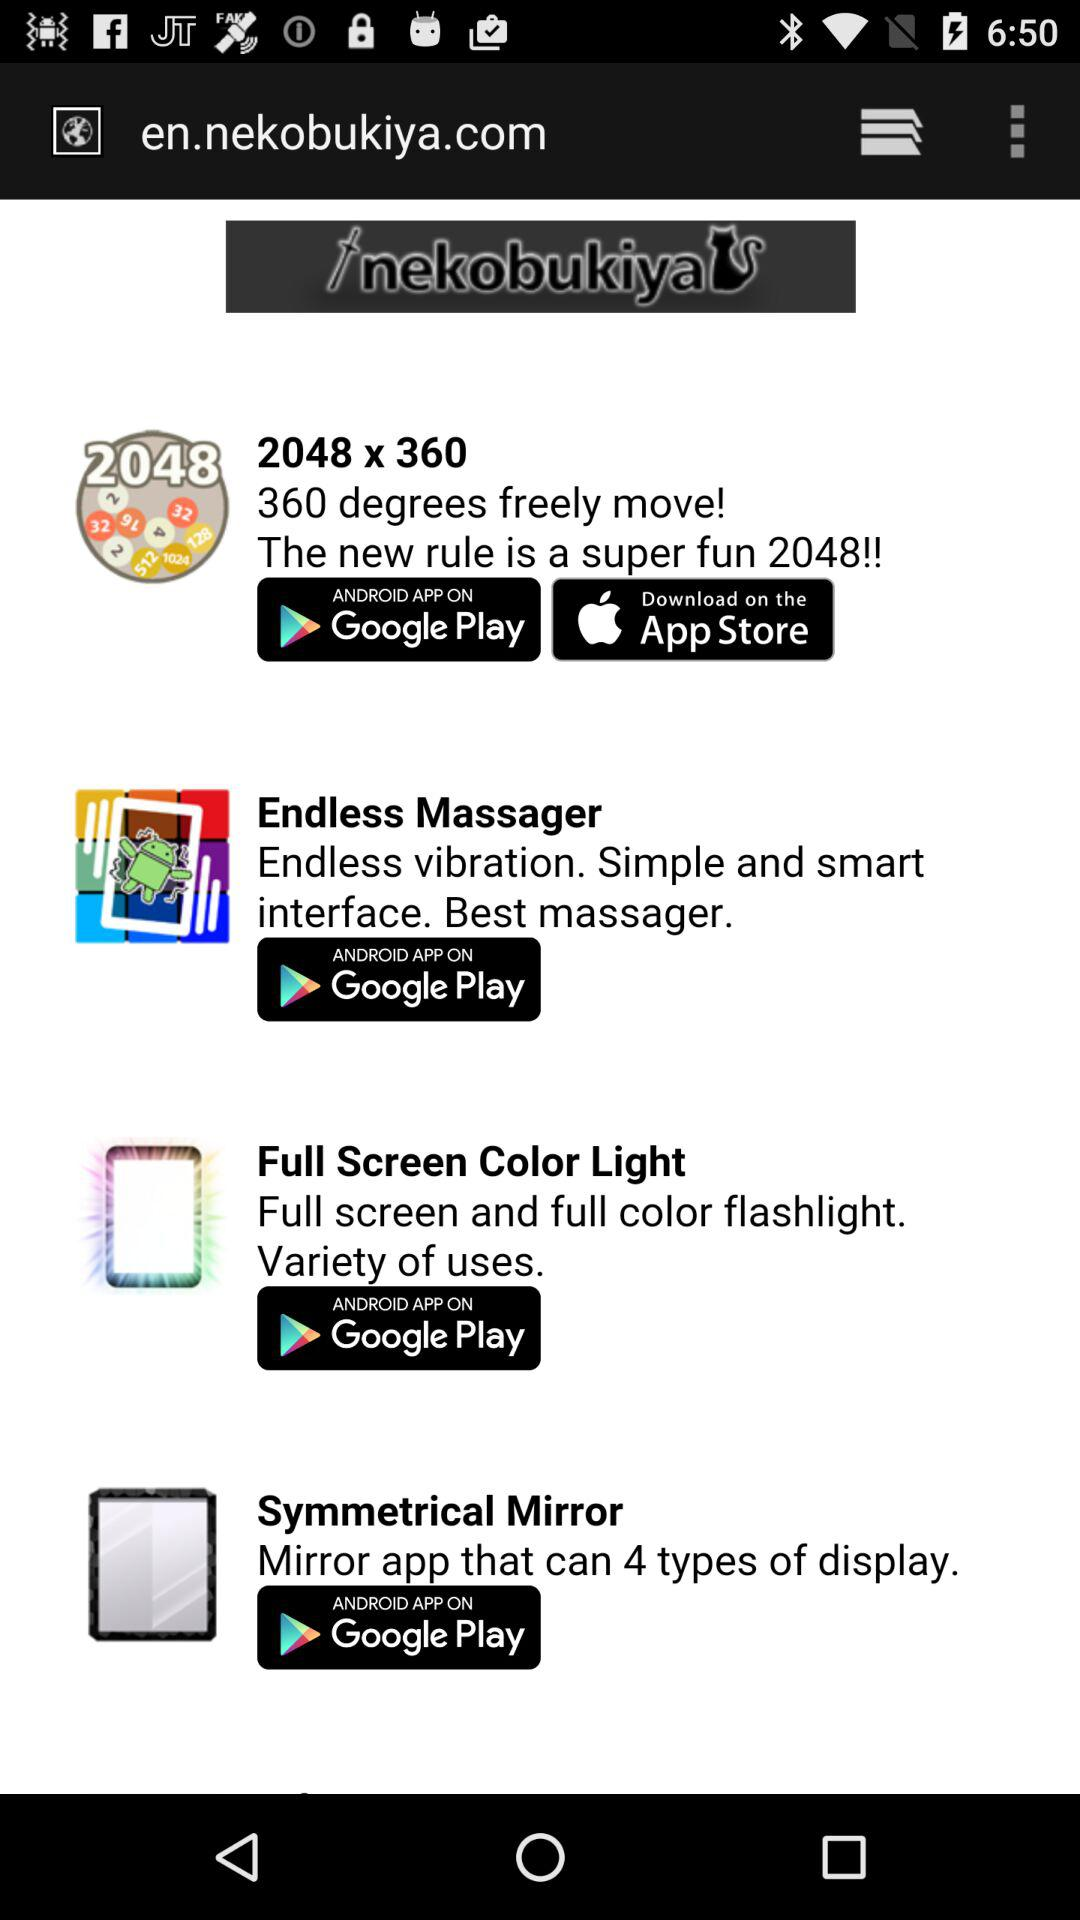What app has 360-degree free movement? The app is "2048 x 360". 